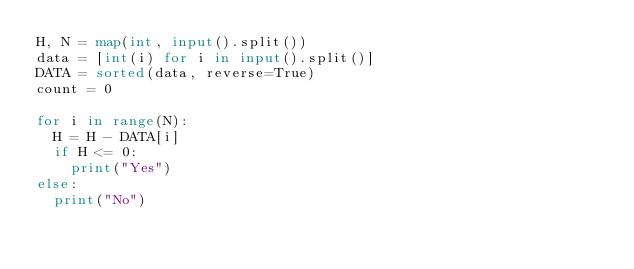Convert code to text. <code><loc_0><loc_0><loc_500><loc_500><_Python_>H, N = map(int, input().split())
data = [int(i) for i in input().split()]
DATA = sorted(data, reverse=True)
count = 0

for i in range(N):
  H = H - DATA[i]
  if H <= 0:
    print("Yes")
else:
  print("No")</code> 